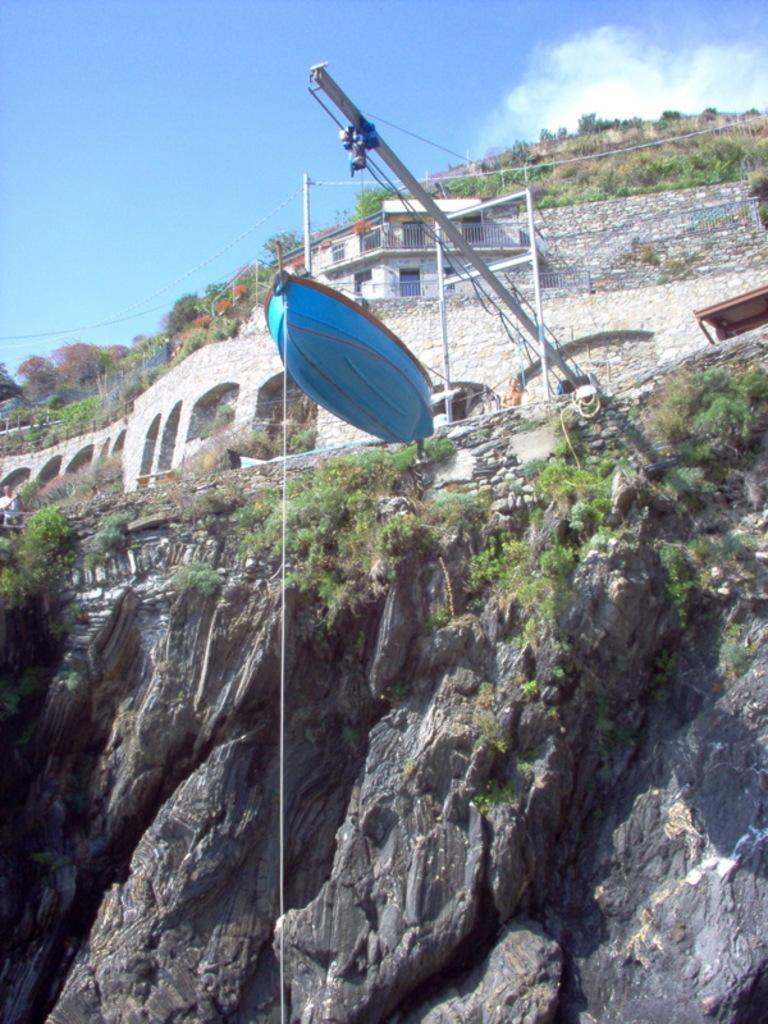What is the main subject in the center of the image? There is a blue color boat in the center of the image. What can be seen in the background of the image? There is a mountain in the background of the image. Are there any structures on the mountain? Yes, there is a house is present on the mountain. What is visible at the top of the image? The sky is visible at the top of the image. What type of scent can be detected from the boat in the image? There is no information about any scent in the image, as it only shows a blue color boat, a mountain, a house, and the sky. 